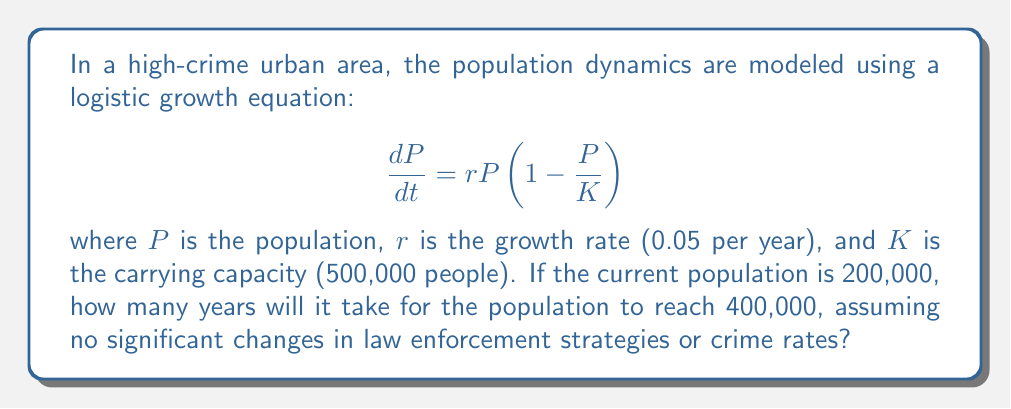Solve this math problem. To solve this problem, we'll use the integrated form of the logistic growth equation:

$$P(t) = \frac{K}{1 + (\frac{K}{P_0} - 1)e^{-rt}}$$

Where:
$P(t)$ is the population at time $t$
$K$ = 500,000 (carrying capacity)
$P_0$ = 200,000 (initial population)
$r$ = 0.05 (growth rate)

We want to find $t$ when $P(t) = 400,000$. Let's solve step-by-step:

1) Substitute the known values into the equation:

   $$400,000 = \frac{500,000}{1 + (\frac{500,000}{200,000} - 1)e^{-0.05t}}$$

2) Simplify:

   $$400,000 = \frac{500,000}{1 + 1.5e^{-0.05t}}$$

3) Multiply both sides by $(1 + 1.5e^{-0.05t})$:

   $$400,000(1 + 1.5e^{-0.05t}) = 500,000$$

4) Expand:

   $$400,000 + 600,000e^{-0.05t} = 500,000$$

5) Subtract 400,000 from both sides:

   $$600,000e^{-0.05t} = 100,000$$

6) Divide both sides by 600,000:

   $$e^{-0.05t} = \frac{1}{6}$$

7) Take the natural log of both sides:

   $$-0.05t = \ln(\frac{1}{6})$$

8) Solve for $t$:

   $$t = -\frac{\ln(\frac{1}{6})}{0.05} \approx 35.67$$

Therefore, it will take approximately 35.67 years for the population to reach 400,000.
Answer: 35.67 years 